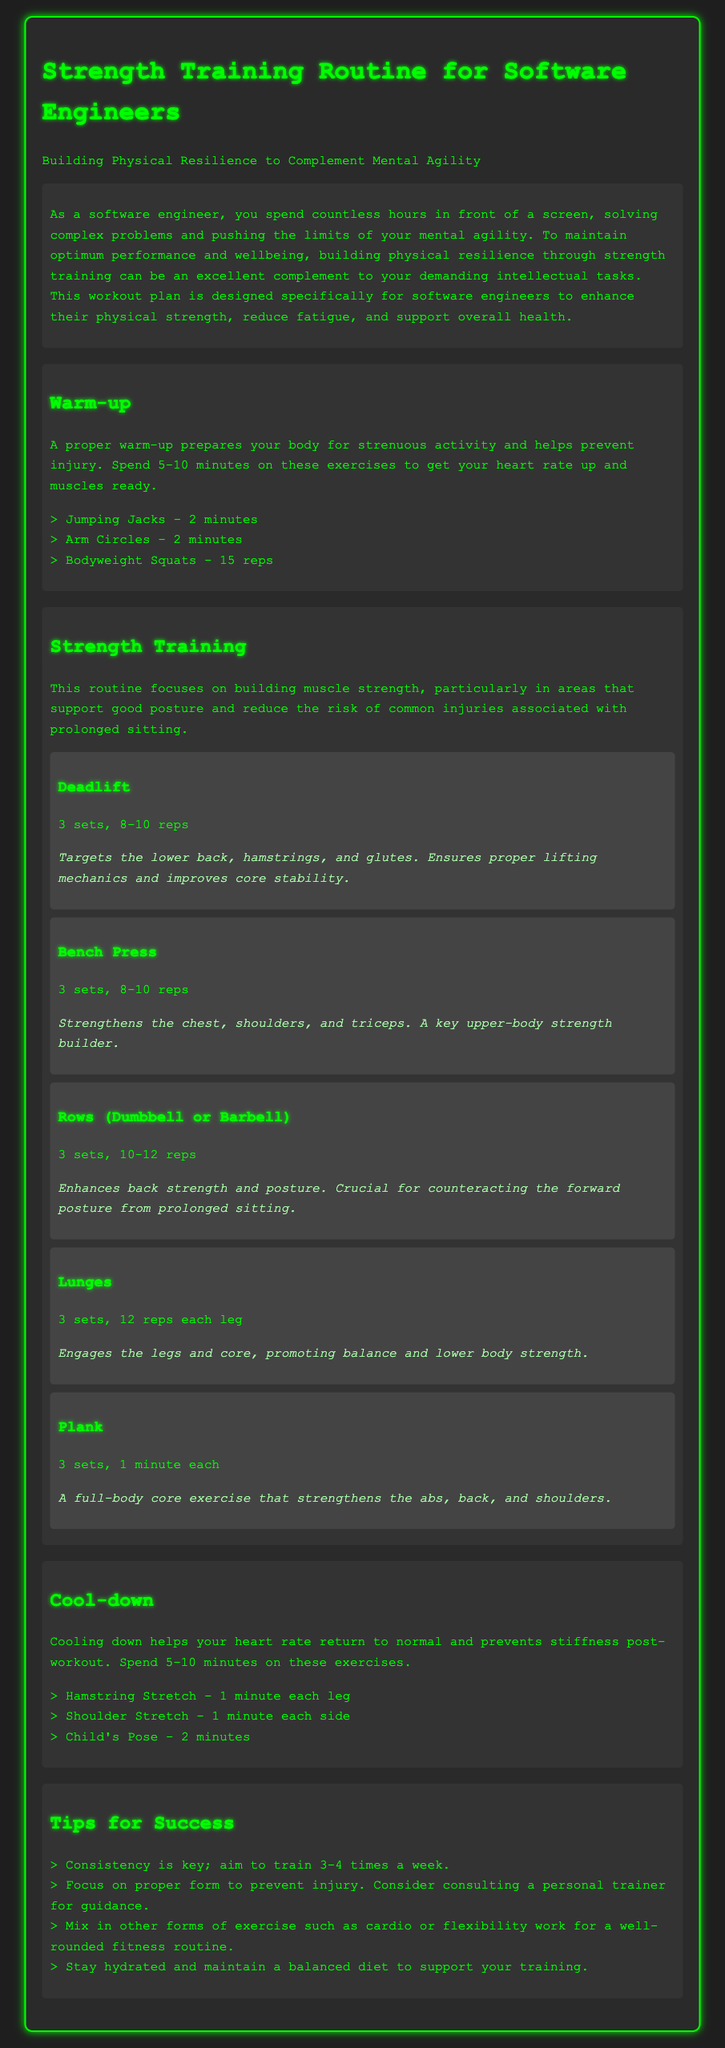What is the focus of the strength training routine? The routine focuses on building muscle strength, particularly in areas that support good posture and reduce injury risks associated with prolonged sitting.
Answer: Building muscle strength How many sets of deadlifts are recommended? The document states that deadlifts should be performed in 3 sets.
Answer: 3 sets What is the duration of the warm-up exercises? The warm-up should take about 5-10 minutes, as mentioned in the document.
Answer: 5-10 minutes What is the primary benefit of the plank exercise? The plank strengthens the abs, back, and shoulders, contributing to overall core stability.
Answer: Core strength How many reps are suggested for lunges? The document recommends performing 12 reps for each leg during the lunge exercise.
Answer: 12 reps each leg What should be avoided to prevent injury? The document emphasizes the importance of focusing on proper form to prevent injury.
Answer: Proper form How often should one aim to train according to the tips? The document suggests training 3-4 times a week for consistency.
Answer: 3-4 times a week 